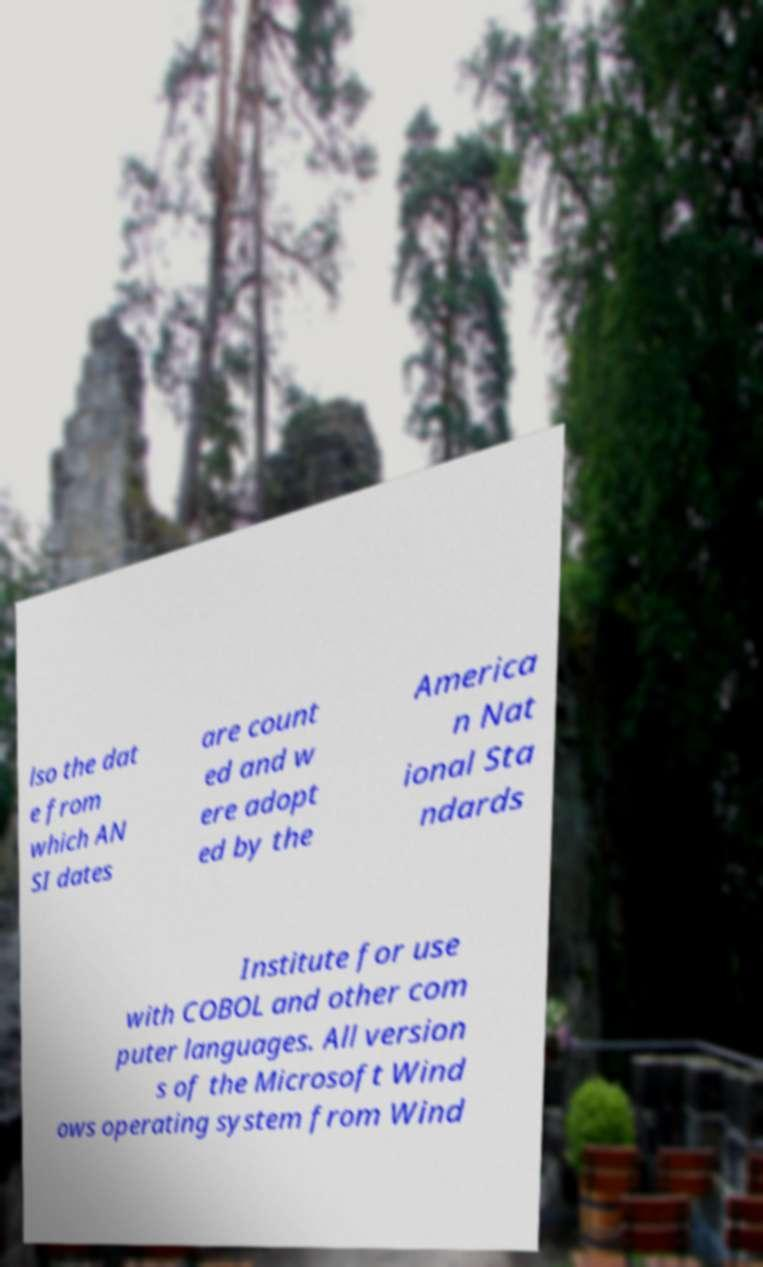For documentation purposes, I need the text within this image transcribed. Could you provide that? lso the dat e from which AN SI dates are count ed and w ere adopt ed by the America n Nat ional Sta ndards Institute for use with COBOL and other com puter languages. All version s of the Microsoft Wind ows operating system from Wind 